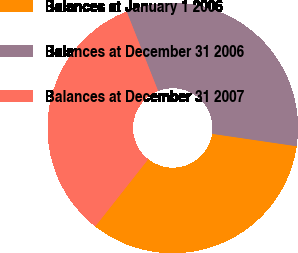Convert chart. <chart><loc_0><loc_0><loc_500><loc_500><pie_chart><fcel>Balances at January 1 2006<fcel>Balances at December 31 2006<fcel>Balances at December 31 2007<nl><fcel>33.3%<fcel>33.33%<fcel>33.37%<nl></chart> 